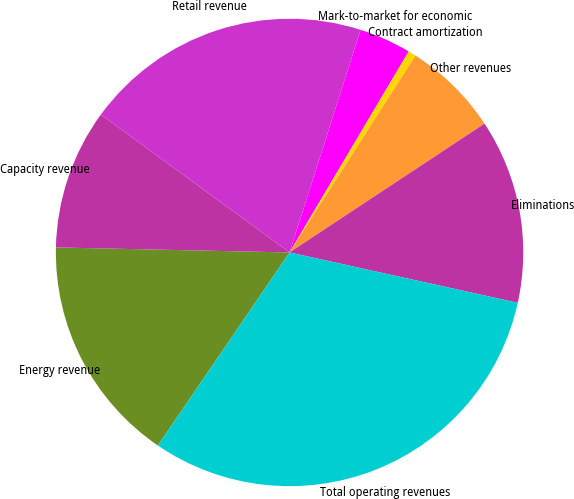Convert chart. <chart><loc_0><loc_0><loc_500><loc_500><pie_chart><fcel>Energy revenue<fcel>Capacity revenue<fcel>Retail revenue<fcel>Mark-to-market for economic<fcel>Contract amortization<fcel>Other revenues<fcel>Eliminations<fcel>Total operating revenues<nl><fcel>15.81%<fcel>9.7%<fcel>19.87%<fcel>3.6%<fcel>0.54%<fcel>6.65%<fcel>12.75%<fcel>31.07%<nl></chart> 